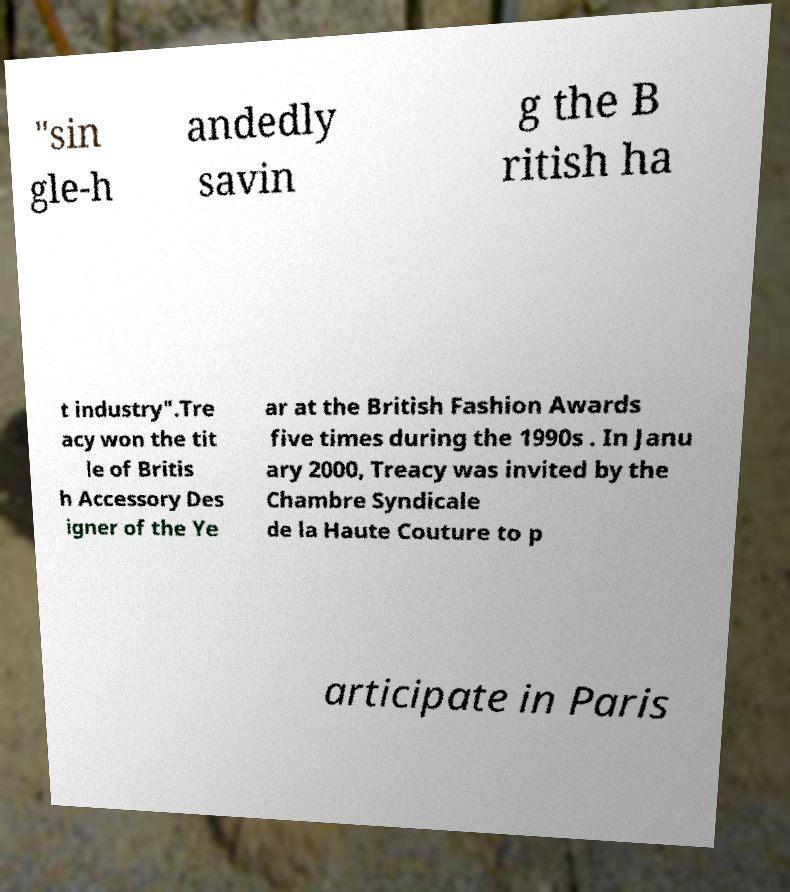There's text embedded in this image that I need extracted. Can you transcribe it verbatim? "sin gle-h andedly savin g the B ritish ha t industry".Tre acy won the tit le of Britis h Accessory Des igner of the Ye ar at the British Fashion Awards five times during the 1990s . In Janu ary 2000, Treacy was invited by the Chambre Syndicale de la Haute Couture to p articipate in Paris 